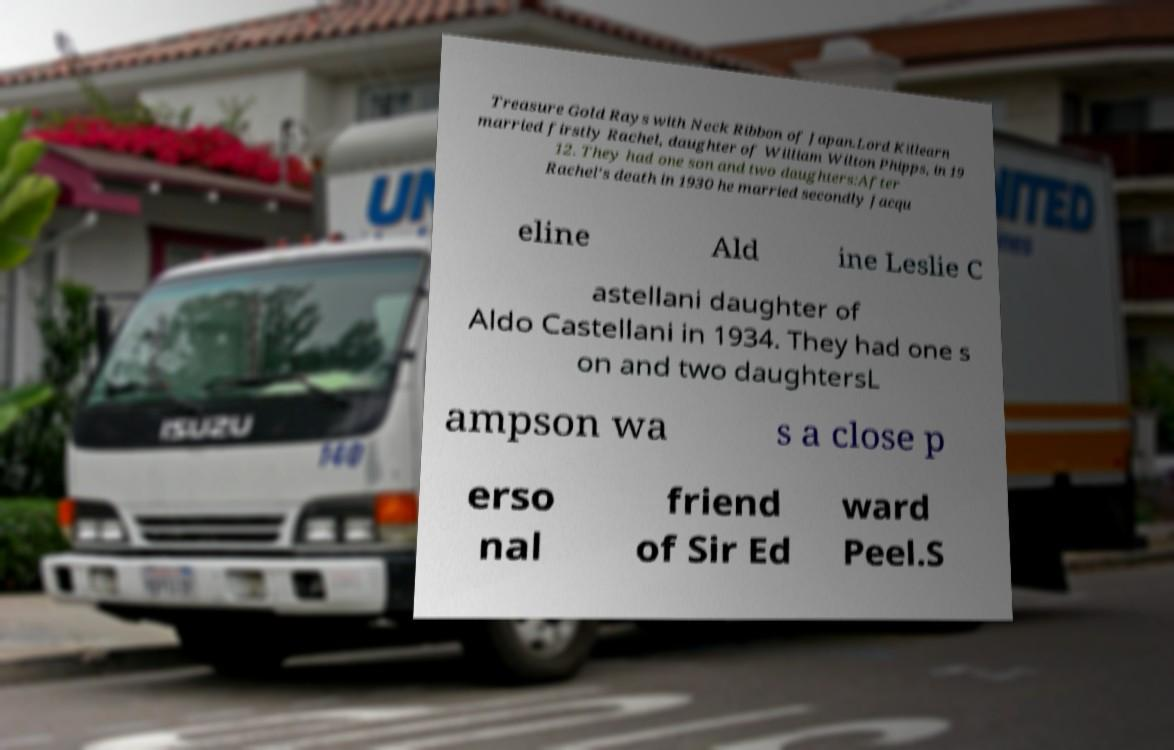Please read and relay the text visible in this image. What does it say? Treasure Gold Rays with Neck Ribbon of Japan.Lord Killearn married firstly Rachel, daughter of William Wilton Phipps, in 19 12. They had one son and two daughters:After Rachel's death in 1930 he married secondly Jacqu eline Ald ine Leslie C astellani daughter of Aldo Castellani in 1934. They had one s on and two daughtersL ampson wa s a close p erso nal friend of Sir Ed ward Peel.S 